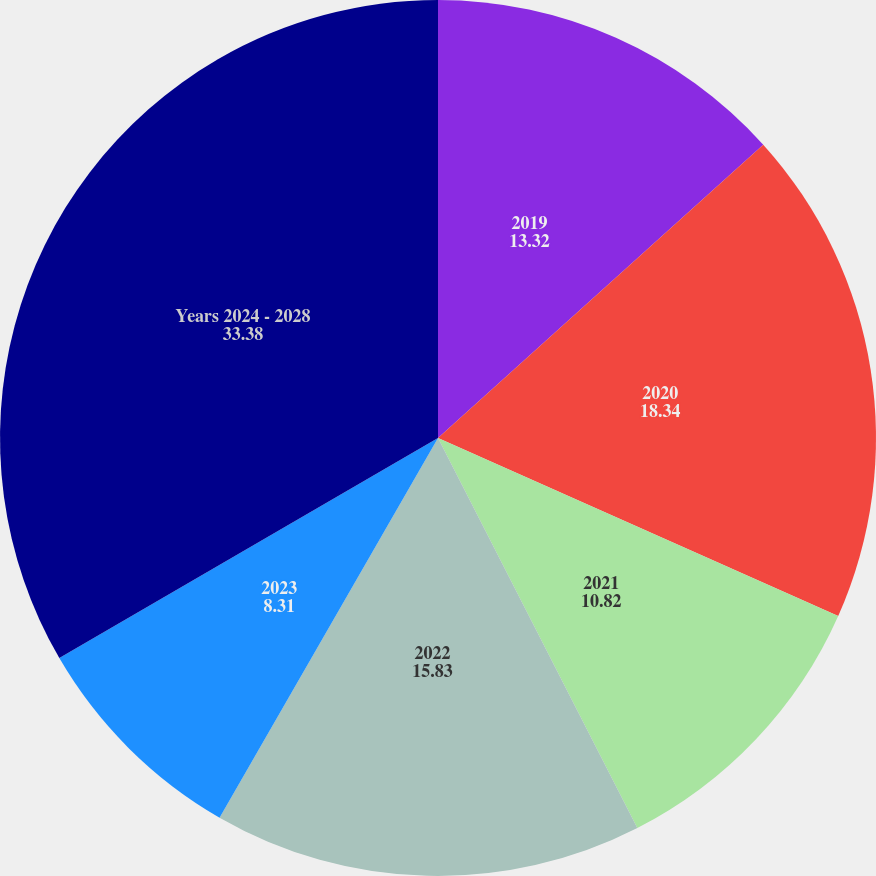Convert chart to OTSL. <chart><loc_0><loc_0><loc_500><loc_500><pie_chart><fcel>2019<fcel>2020<fcel>2021<fcel>2022<fcel>2023<fcel>Years 2024 - 2028<nl><fcel>13.32%<fcel>18.34%<fcel>10.82%<fcel>15.83%<fcel>8.31%<fcel>33.38%<nl></chart> 